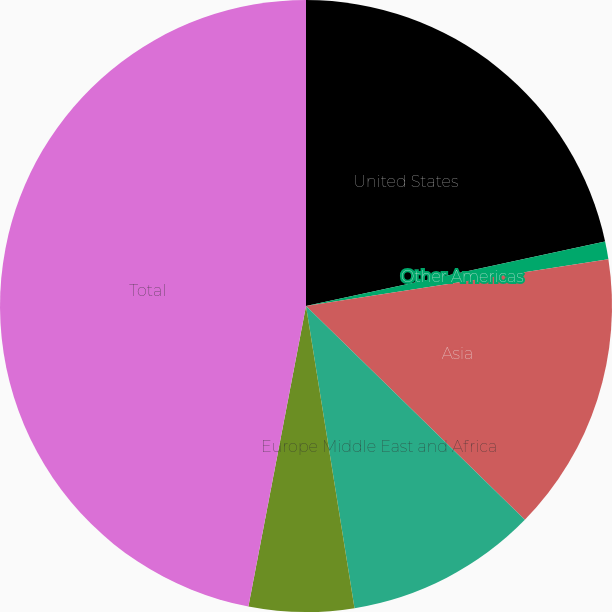Convert chart to OTSL. <chart><loc_0><loc_0><loc_500><loc_500><pie_chart><fcel>United States<fcel>Other Americas<fcel>Asia<fcel>Europe Middle East and Africa<fcel>Japan<fcel>Total<nl><fcel>21.62%<fcel>0.94%<fcel>14.76%<fcel>10.15%<fcel>5.55%<fcel>46.99%<nl></chart> 